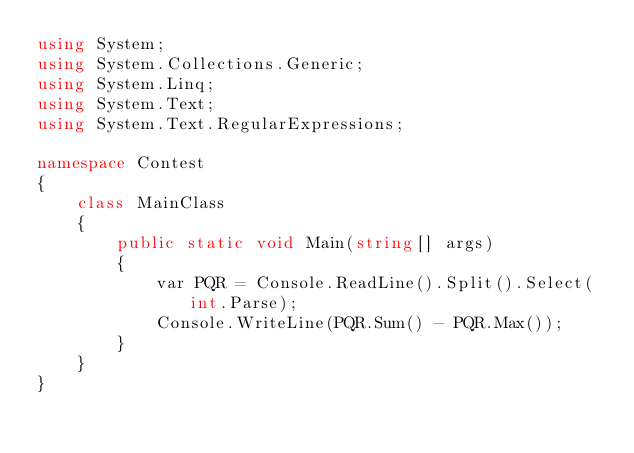<code> <loc_0><loc_0><loc_500><loc_500><_C#_>using System;
using System.Collections.Generic;
using System.Linq;
using System.Text;
using System.Text.RegularExpressions;

namespace Contest
{
    class MainClass
    {
        public static void Main(string[] args)
        {
            var PQR = Console.ReadLine().Split().Select(int.Parse);
            Console.WriteLine(PQR.Sum() - PQR.Max());
        }
    }
}
</code> 